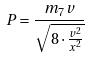Convert formula to latex. <formula><loc_0><loc_0><loc_500><loc_500>P = \frac { m _ { 7 } v } { \sqrt { 8 \cdot \frac { v ^ { 2 } } { x ^ { 2 } } } }</formula> 